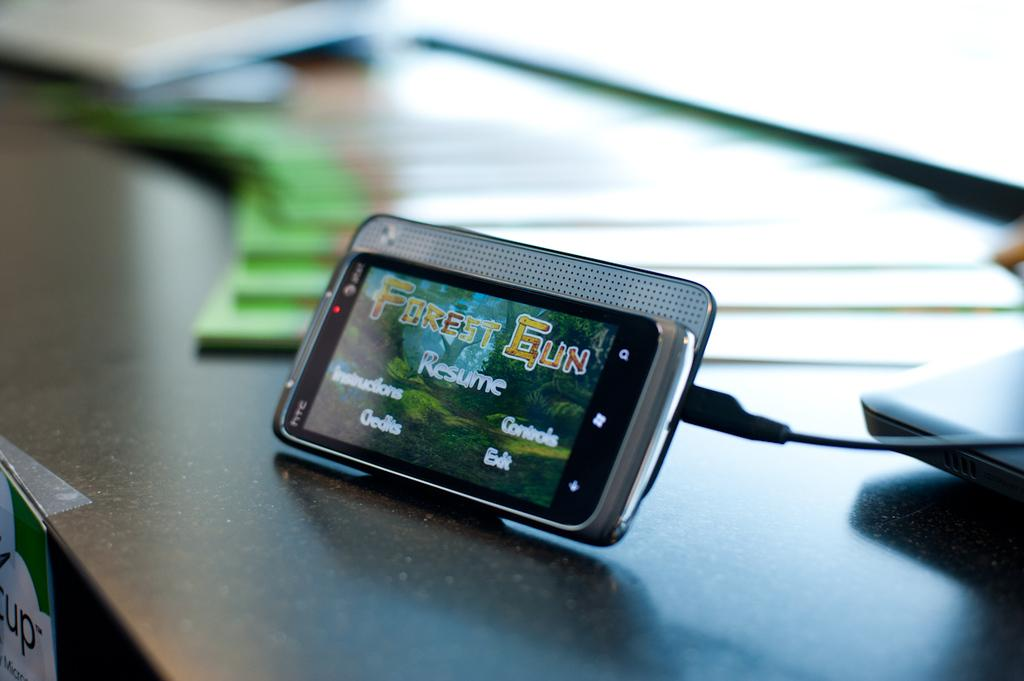<image>
Present a compact description of the photo's key features. htc phone at an angle running forest gun game 